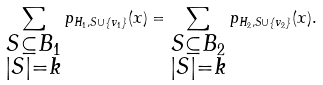<formula> <loc_0><loc_0><loc_500><loc_500>\sum _ { \substack { S \subseteq B _ { 1 } \\ | S | = k } } p _ { H _ { 1 } , S \cup \{ v _ { 1 } \} } ( x ) = \sum _ { \substack { S \subseteq B _ { 2 } \\ | S | = k } } p _ { H _ { 2 } , S \cup \{ v _ { 2 } \} } ( x ) .</formula> 